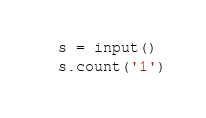<code> <loc_0><loc_0><loc_500><loc_500><_Python_>s = input()
s.count('1')</code> 